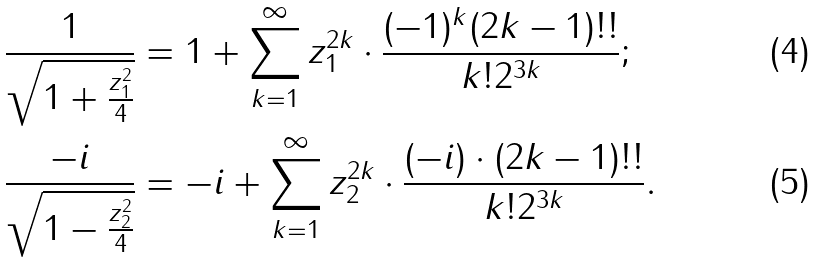<formula> <loc_0><loc_0><loc_500><loc_500>\frac { 1 } { \sqrt { 1 + \frac { z _ { 1 } ^ { 2 } } { 4 } } } & = 1 + \sum _ { k = 1 } ^ { \infty } z _ { 1 } ^ { 2 k } \cdot \frac { ( - 1 ) ^ { k } ( 2 k - 1 ) ! ! } { k ! 2 ^ { 3 k } } ; \\ \frac { - i } { \sqrt { 1 - \frac { z _ { 2 } ^ { 2 } } { 4 } } } & = - i + \sum _ { k = 1 } ^ { \infty } z _ { 2 } ^ { 2 k } \cdot \frac { ( - i ) \cdot ( 2 k - 1 ) ! ! } { k ! 2 ^ { 3 k } } .</formula> 